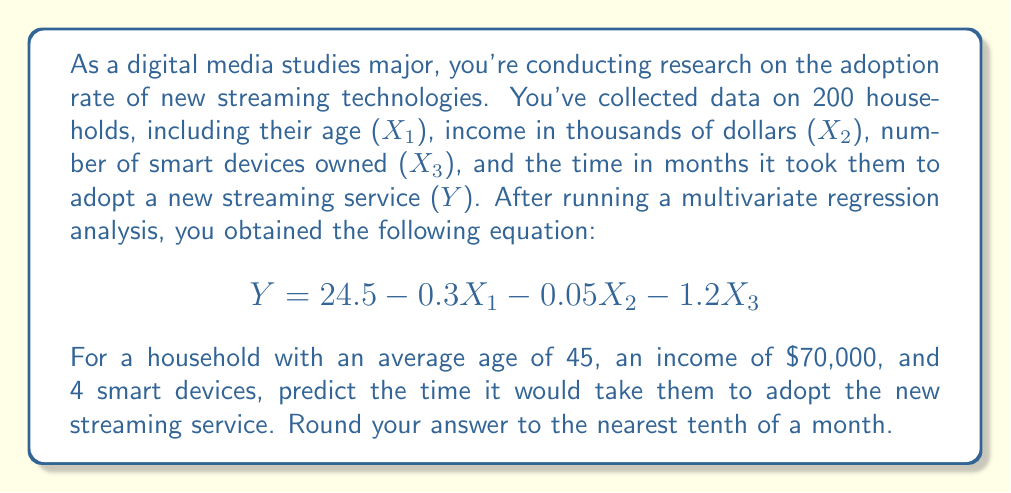Give your solution to this math problem. To solve this problem, we'll follow these steps:

1. Identify the given information:
   - Regression equation: $Y = 24.5 - 0.3X_1 - 0.05X_2 - 1.2X_3$
   - $X_1$ (age) = 45
   - $X_2$ (income in thousands) = 70
   - $X_3$ (number of smart devices) = 4

2. Substitute the values into the equation:
   $$ Y = 24.5 - 0.3(45) - 0.05(70) - 1.2(4) $$

3. Calculate each term:
   - $24.5$ (constant term)
   - $-0.3(45) = -13.5$
   - $-0.05(70) = -3.5$
   - $-1.2(4) = -4.8$

4. Sum up all the terms:
   $$ Y = 24.5 - 13.5 - 3.5 - 4.8 $$
   $$ Y = 2.7 $$

5. Round to the nearest tenth:
   $Y \approx 2.7$ months
Answer: 2.7 months 